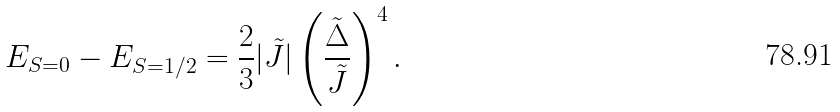Convert formula to latex. <formula><loc_0><loc_0><loc_500><loc_500>E _ { S = 0 } - E _ { S = 1 / 2 } = \frac { 2 } { 3 } | \tilde { J } | \left ( \frac { \tilde { \Delta } } { \tilde { J } } \right ) ^ { 4 } .</formula> 